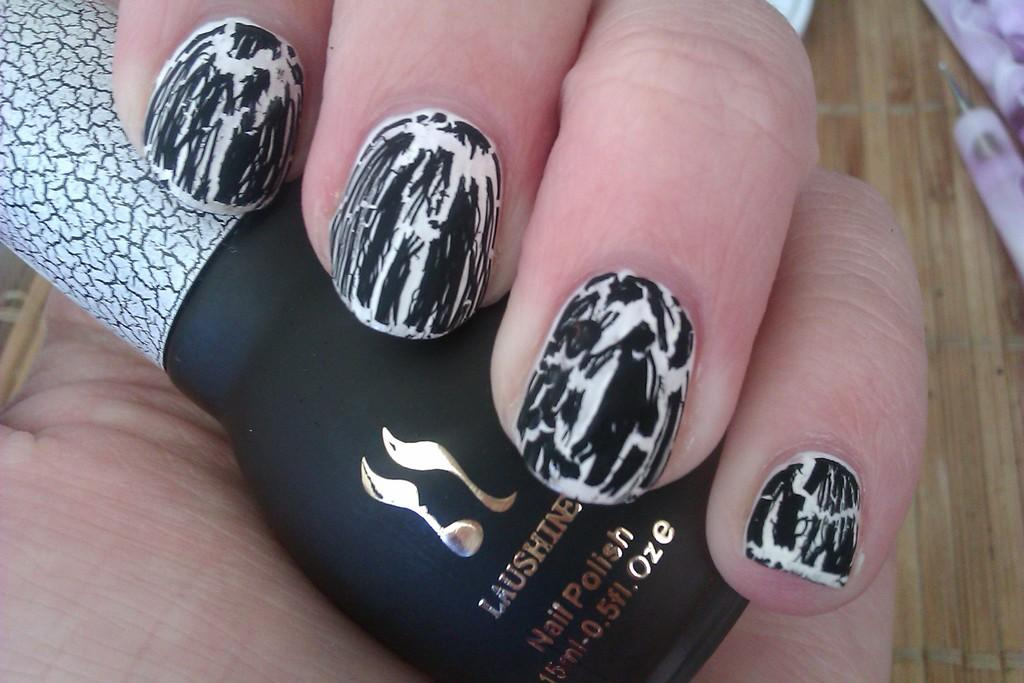What is the person's hand holding in the image? The person's hand is holding nail polish in the image. What can be seen on the wooden floor at the bottom of the image? There are objects on the wooden floor at the bottom of the image. What type of temper can be seen in the person's hand in the image? There is no temper present in the image; it is a person's hand holding nail polish. What kind of error is being corrected by the person in the image? There is no indication of an error or any corrective action being taken in the image. 